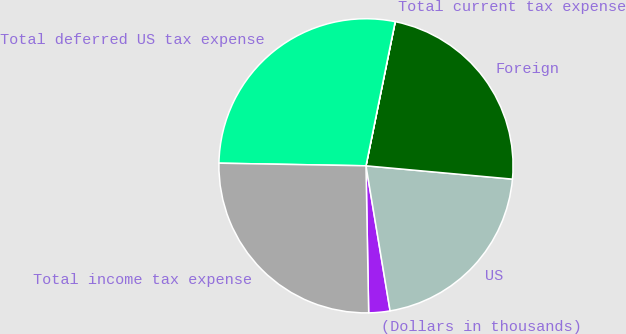Convert chart. <chart><loc_0><loc_0><loc_500><loc_500><pie_chart><fcel>(Dollars in thousands)<fcel>US<fcel>Foreign<fcel>Total current tax expense<fcel>Total deferred US tax expense<fcel>Total income tax expense<nl><fcel>2.33%<fcel>20.94%<fcel>23.26%<fcel>0.01%<fcel>27.9%<fcel>25.58%<nl></chart> 